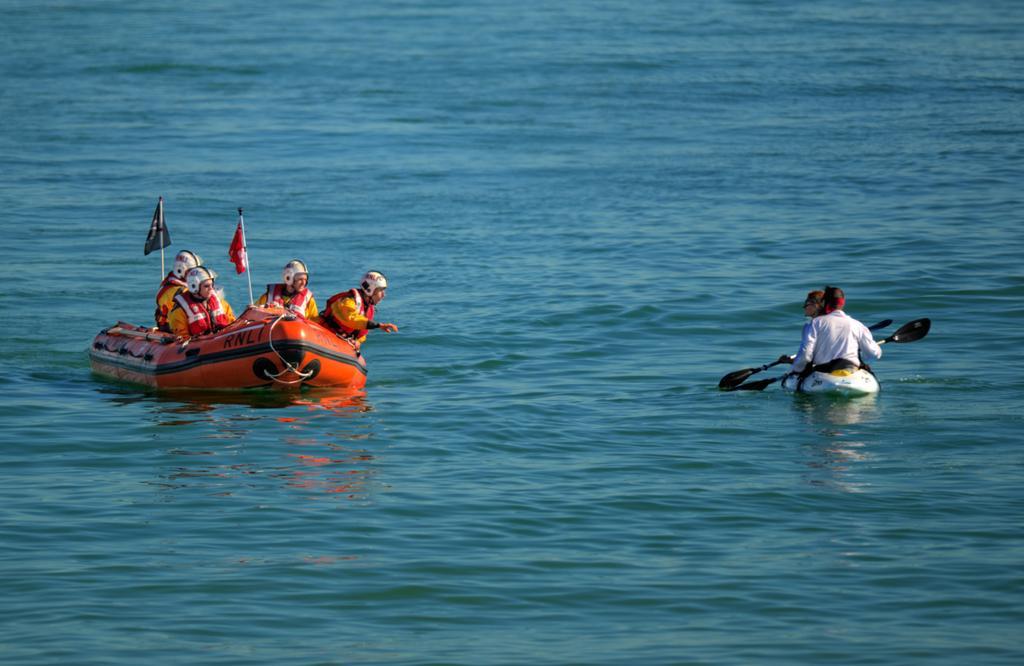Could you give a brief overview of what you see in this image? In this picture we can see flags and some people wore helmets, jackets and beside them we can see two people holding paddles with their hands and they all are on boats and these boats are on the water. 